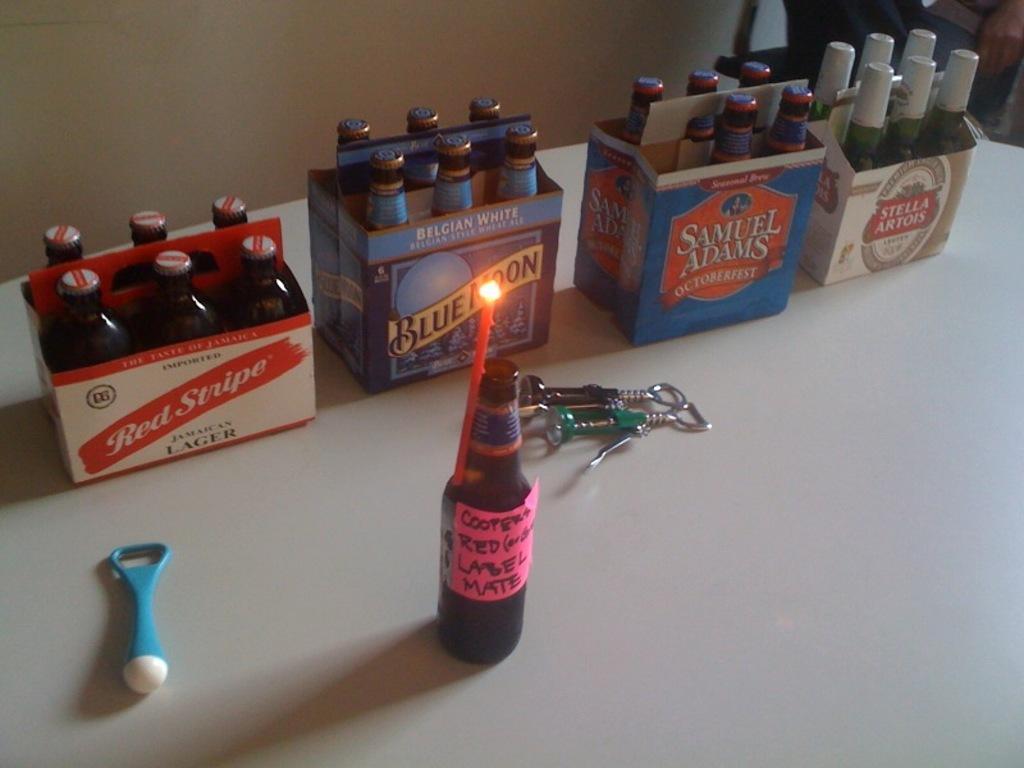Could you give a brief overview of what you see in this image? In this picture we can see few bottles in a box on the table. these are openers. This is a candle which is tied to a bottle. This is also an opener in blue colour. On the background we can see a wall. 